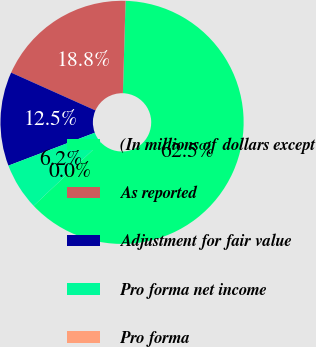Convert chart to OTSL. <chart><loc_0><loc_0><loc_500><loc_500><pie_chart><fcel>(In millions of dollars except<fcel>As reported<fcel>Adjustment for fair value<fcel>Pro forma net income<fcel>Pro forma<nl><fcel>62.5%<fcel>18.75%<fcel>12.5%<fcel>6.25%<fcel>0.0%<nl></chart> 